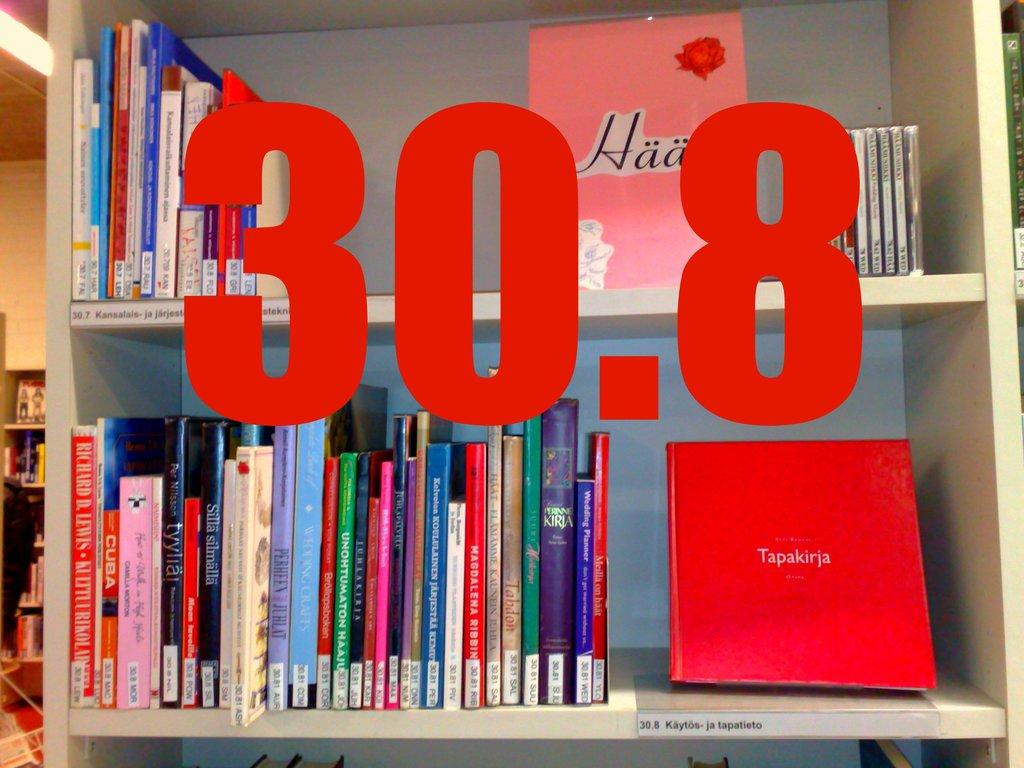What objects are visible in the image? There are books in the image. How are the books arranged in the image? The books are kept in racks. Can you identify any specific details about the books or racks? There is a numerical number present in the image. What type of metal is used to construct the spacecraft in the image? There is no spacecraft or metal present in the image; it features books in racks with a numerical number. 